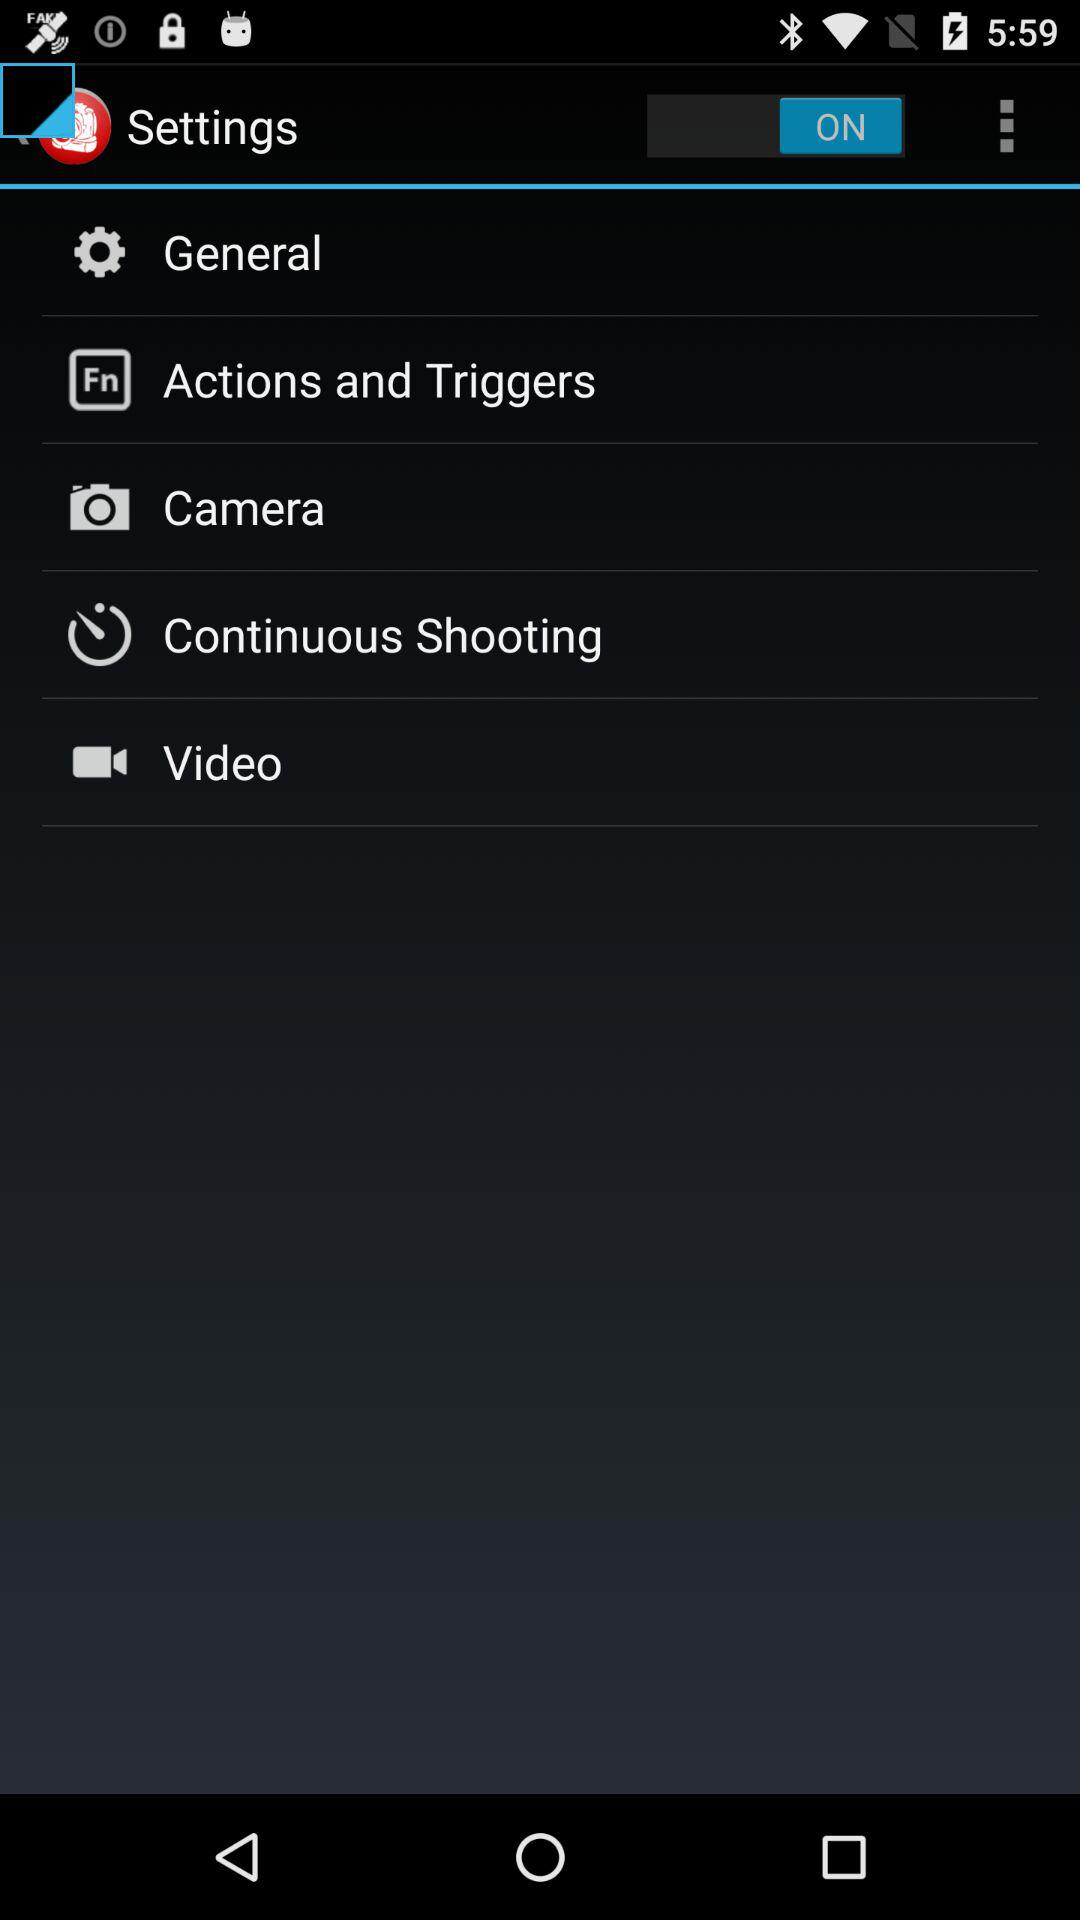How many notifications are there in "General"?
When the provided information is insufficient, respond with <no answer>. <no answer> 